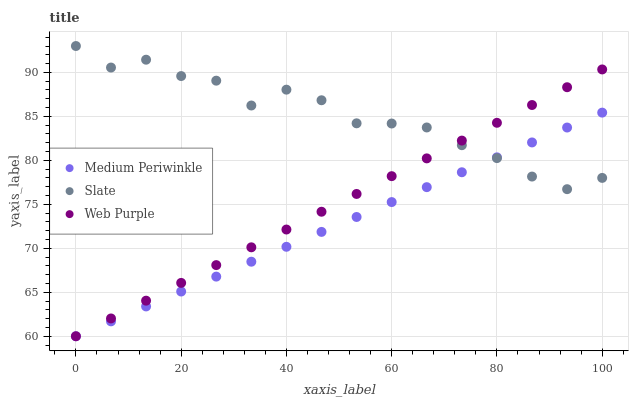Does Medium Periwinkle have the minimum area under the curve?
Answer yes or no. Yes. Does Slate have the maximum area under the curve?
Answer yes or no. Yes. Does Web Purple have the minimum area under the curve?
Answer yes or no. No. Does Web Purple have the maximum area under the curve?
Answer yes or no. No. Is Medium Periwinkle the smoothest?
Answer yes or no. Yes. Is Slate the roughest?
Answer yes or no. Yes. Is Web Purple the smoothest?
Answer yes or no. No. Is Web Purple the roughest?
Answer yes or no. No. Does Medium Periwinkle have the lowest value?
Answer yes or no. Yes. Does Slate have the highest value?
Answer yes or no. Yes. Does Web Purple have the highest value?
Answer yes or no. No. Does Web Purple intersect Medium Periwinkle?
Answer yes or no. Yes. Is Web Purple less than Medium Periwinkle?
Answer yes or no. No. Is Web Purple greater than Medium Periwinkle?
Answer yes or no. No. 